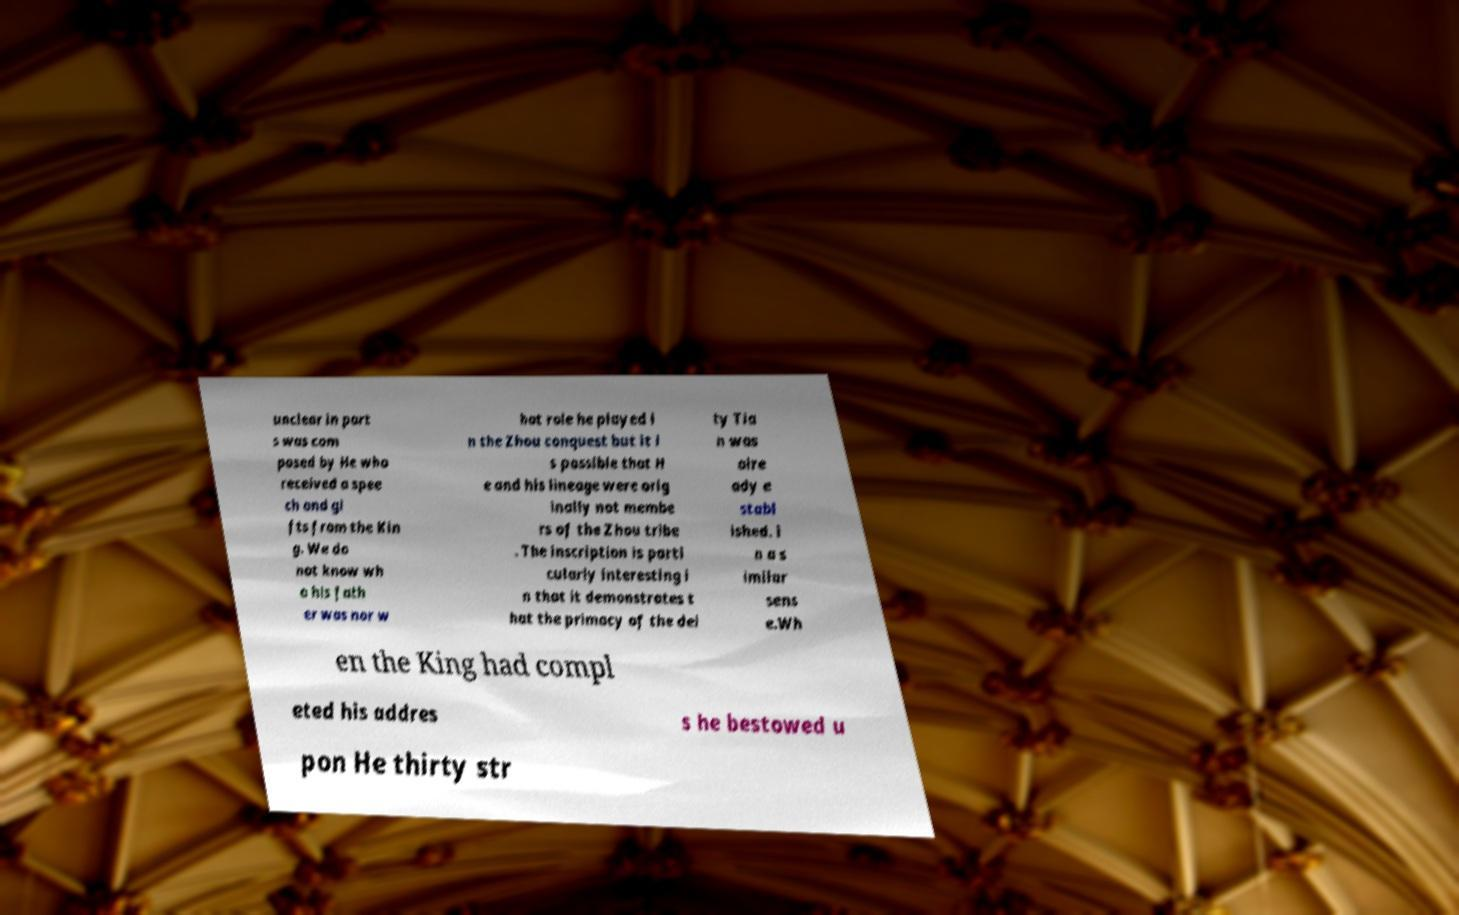Could you extract and type out the text from this image? unclear in part s was com posed by He who received a spee ch and gi fts from the Kin g. We do not know wh o his fath er was nor w hat role he played i n the Zhou conquest but it i s possible that H e and his lineage were orig inally not membe rs of the Zhou tribe . The inscription is parti cularly interesting i n that it demonstrates t hat the primacy of the dei ty Tia n was alre ady e stabl ished. i n a s imilar sens e.Wh en the King had compl eted his addres s he bestowed u pon He thirty str 